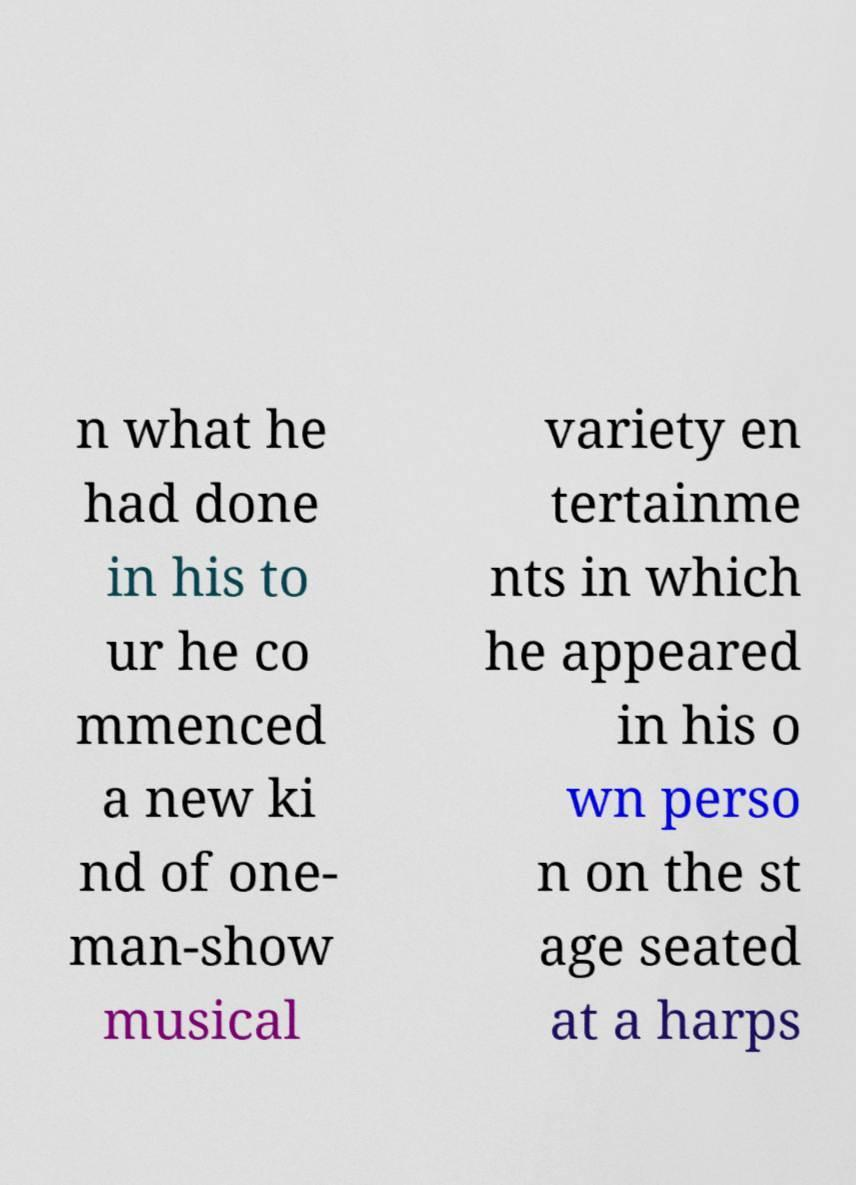There's text embedded in this image that I need extracted. Can you transcribe it verbatim? n what he had done in his to ur he co mmenced a new ki nd of one- man-show musical variety en tertainme nts in which he appeared in his o wn perso n on the st age seated at a harps 